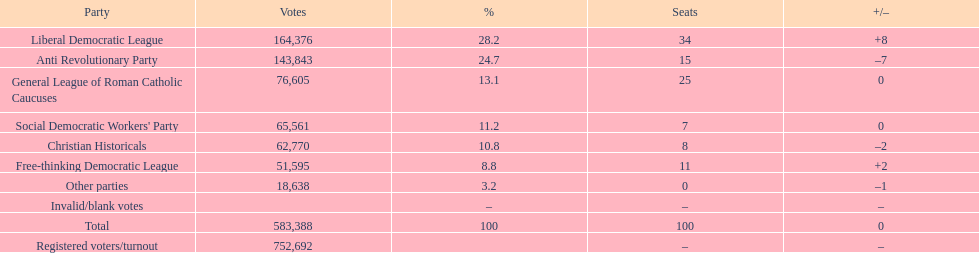How many votes were deemed void or unmarked? 0. 